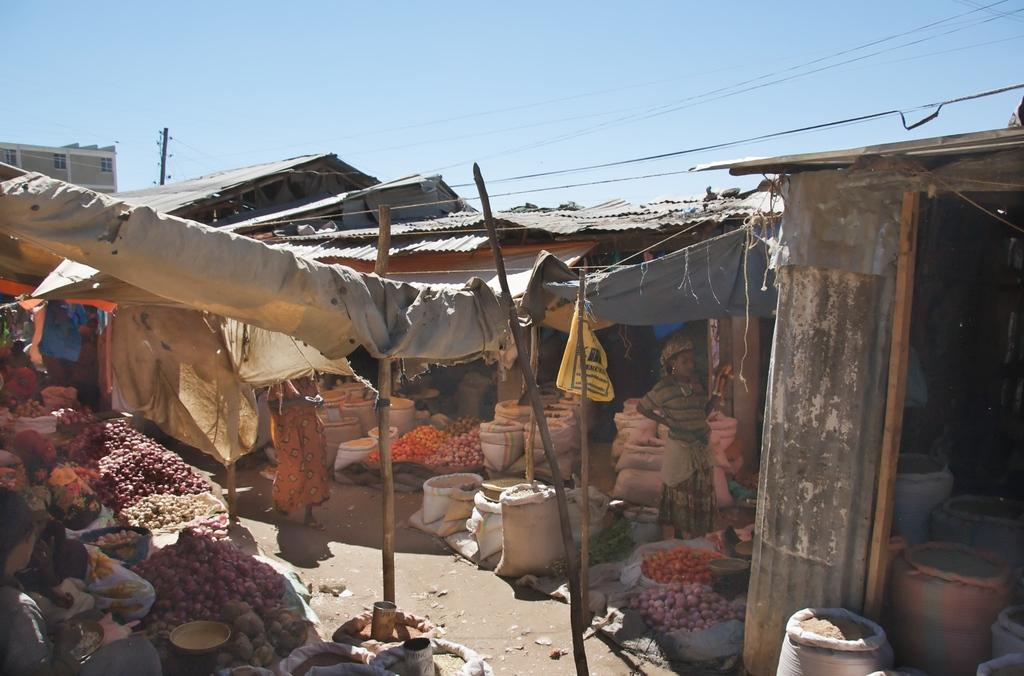What type of market is depicted in the image? The image shows a vegetable market in the foreground. What structures are present in the foreground of the image? There are tin sheds in the foreground of the image. What can be seen in the image that is related to electricity? Wires and poles are present in the image. What type of buildings can be seen in the image? There are buildings in the image. What is visible in the background of the image? The sky is visible in the image. When was the image taken? The image was taken during the day. How many cherries are being sold by the vendor in the image? There is no mention of cherries or a vendor selling them in the image. What memories are the people in the image discussing? The image does not provide any information about the people's conversations or memories. Are the friends in the image enjoying their time together? The image does not show any friends or their interactions, so we cannot determine if they are enjoying their time together. 